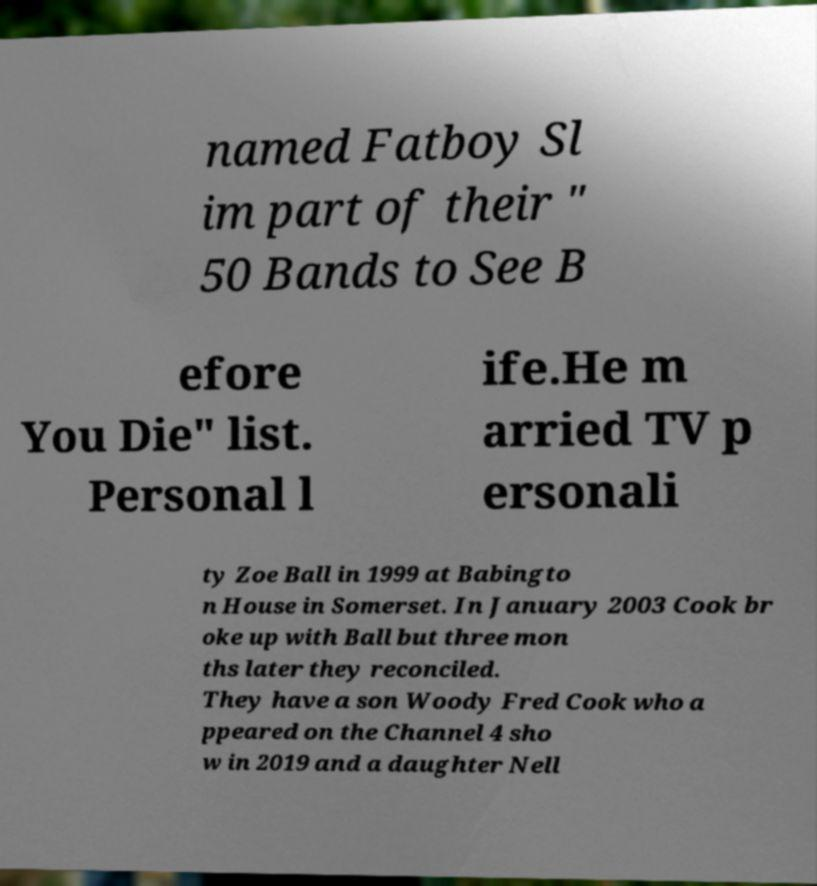For documentation purposes, I need the text within this image transcribed. Could you provide that? named Fatboy Sl im part of their " 50 Bands to See B efore You Die" list. Personal l ife.He m arried TV p ersonali ty Zoe Ball in 1999 at Babingto n House in Somerset. In January 2003 Cook br oke up with Ball but three mon ths later they reconciled. They have a son Woody Fred Cook who a ppeared on the Channel 4 sho w in 2019 and a daughter Nell 